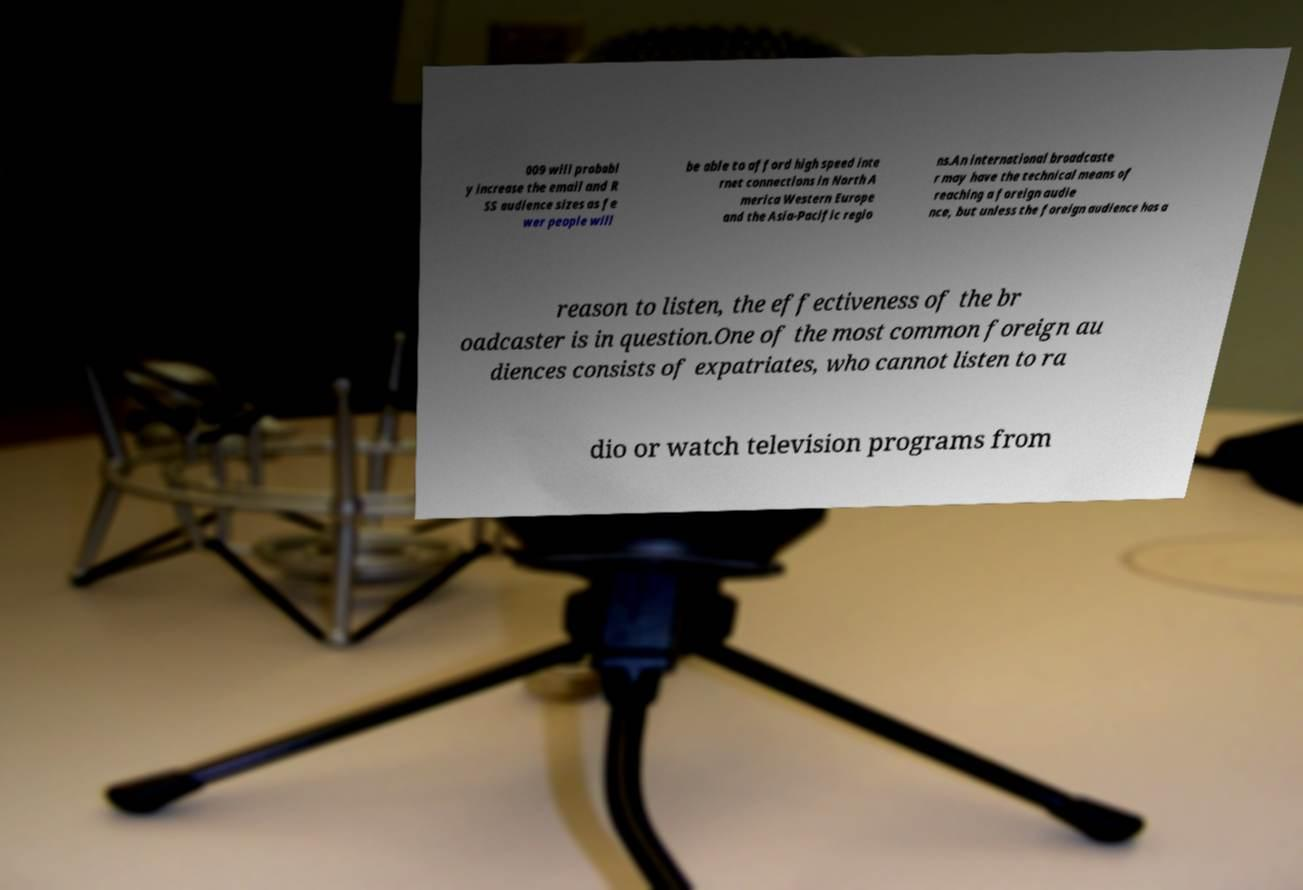Please read and relay the text visible in this image. What does it say? 009 will probabl y increase the email and R SS audience sizes as fe wer people will be able to afford high speed inte rnet connections in North A merica Western Europe and the Asia-Pacific regio ns.An international broadcaste r may have the technical means of reaching a foreign audie nce, but unless the foreign audience has a reason to listen, the effectiveness of the br oadcaster is in question.One of the most common foreign au diences consists of expatriates, who cannot listen to ra dio or watch television programs from 